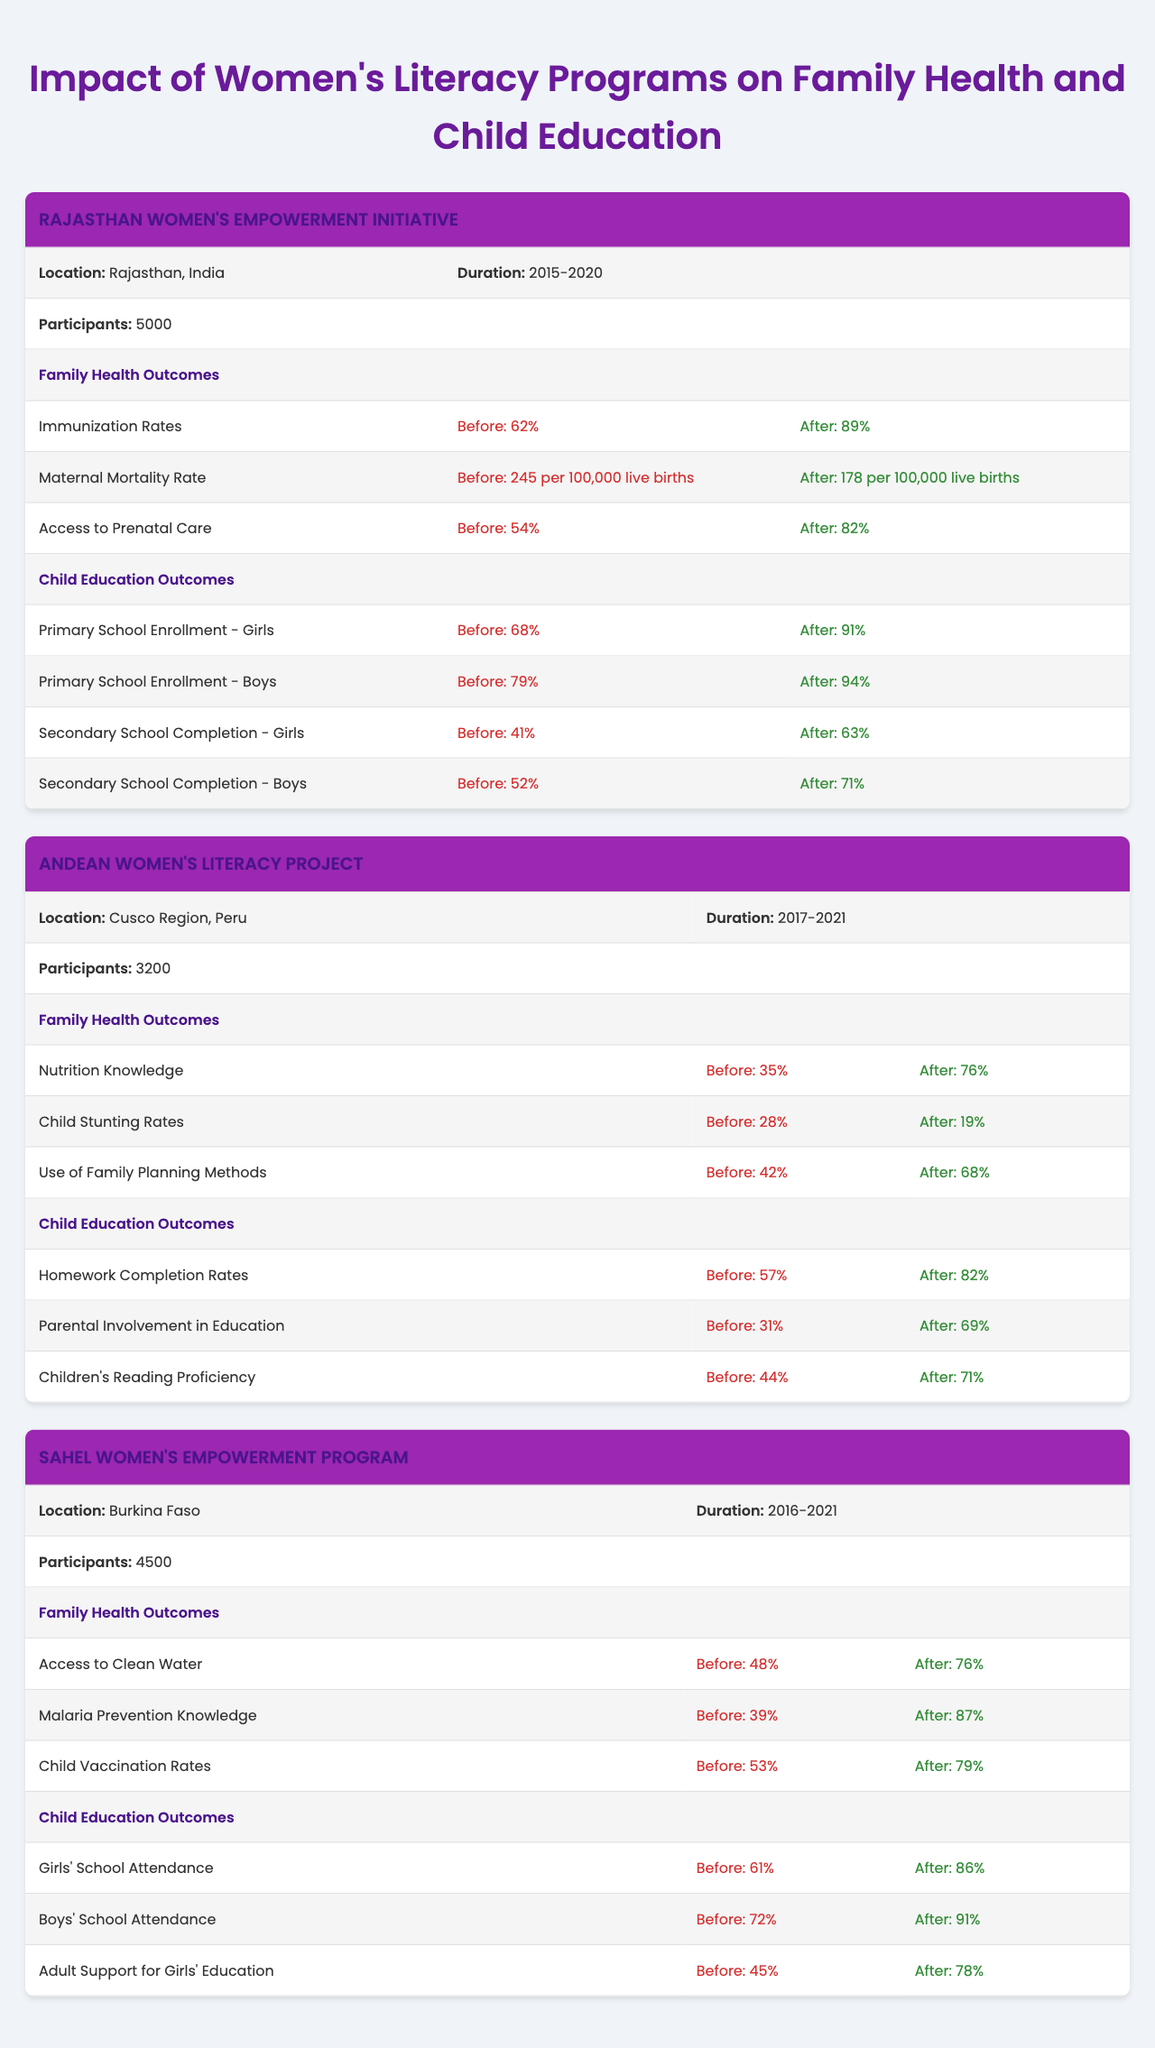What was the immunization rate in Rajasthan before the program? The table shows that the immunization rate before the Rajasthan Women's Empowerment Initiative was 62%.
Answer: 62% What percentage of maternal mortality was reported after the Rajasthan program? After the program, the maternal mortality rate reduced to 178 per 100,000 live births, as indicated in the table.
Answer: 178 per 100,000 live births Which program had the highest improvement in child vaccination rates? Comparing the 'Before' and 'After' values for child vaccination rates, Sahel Women's Empowerment Program improved from 53% to 79%, which is 26%, more than other programs.
Answer: Sahel Women's Empowerment Program Did the Andean Women's Literacy Project improve children's reading proficiency? Yes, the project improved children's reading proficiency from 44% to 71%, which is confirmed by the data.
Answer: Yes What is the difference in primary school enrollment for girls before and after the Rajasthan program? Before the program, girls' primary school enrollment was 68%, which increased to 91% after the program. Thus, the difference is 91% - 68% = 23%.
Answer: 23% True or False: The Sahel Women's Empowerment Program resulted in higher girls' school attendance after the program than before. The attendance for girls increased from 61% to 86%, indicating a positive outcome. Therefore, the statement is true.
Answer: True Which program had the lowest percentage of participants, and what was it? The Andean Women's Literacy Project had the lowest number of participants at 3200, as per the data in the table.
Answer: 3200 Calculate the average percentage of access to prenatal care before the Rajasthan program and the use of family planning methods before the Andean project. Access to prenatal care in Rajasthan was 54%, and the use of family planning methods in Peru was 42%. The average is (54% + 42%) / 2 = 48%.
Answer: 48% What was the maternal mortality rate in Rajasthan before the program compared to after? Before the program, it was 245 per 100,000 live births and after it reduced to 178. This clearly shows a significant decrease in maternal mortality.
Answer: 245 per 100,000 live births before, 178 after After the Andean Women's Literacy Project, by how much did the homework completion rates improve? The homework completion rates increased from 57% to 82%. Thus, the improvement is 82% - 57% = 25%.
Answer: 25% 